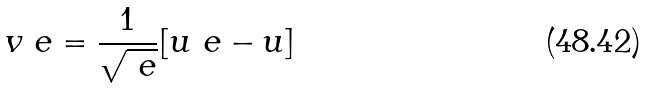<formula> <loc_0><loc_0><loc_500><loc_500>v _ { \ } e = \frac { 1 } { \sqrt { \ e } } [ u _ { \ } e - u ]</formula> 